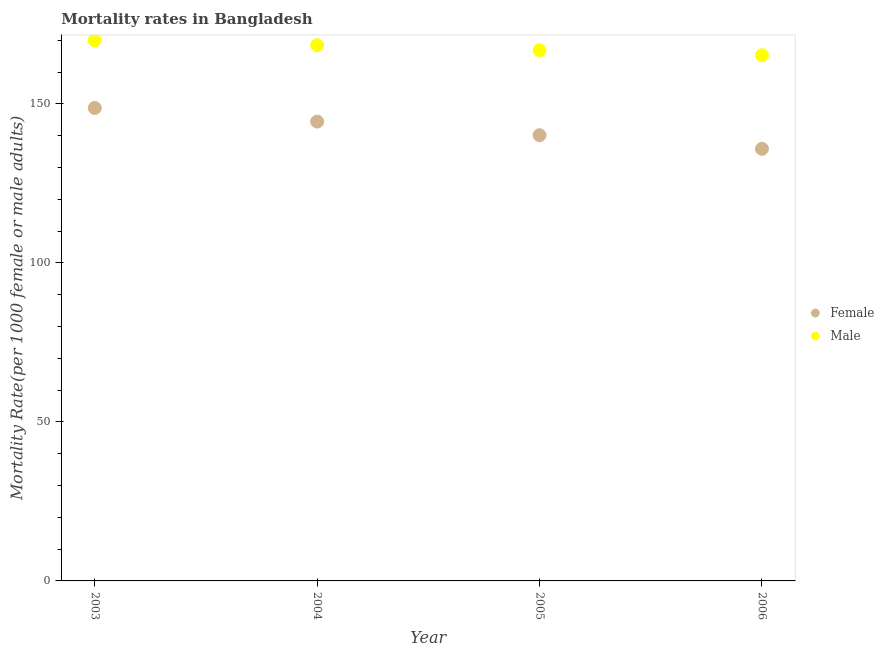What is the female mortality rate in 2004?
Offer a very short reply. 144.42. Across all years, what is the maximum female mortality rate?
Your response must be concise. 148.7. Across all years, what is the minimum male mortality rate?
Make the answer very short. 165.27. In which year was the female mortality rate maximum?
Keep it short and to the point. 2003. In which year was the male mortality rate minimum?
Keep it short and to the point. 2006. What is the total male mortality rate in the graph?
Provide a succinct answer. 670.5. What is the difference between the male mortality rate in 2003 and that in 2005?
Offer a terse response. 3.13. What is the difference between the female mortality rate in 2003 and the male mortality rate in 2005?
Offer a very short reply. -18.14. What is the average male mortality rate per year?
Provide a succinct answer. 167.62. In the year 2005, what is the difference between the female mortality rate and male mortality rate?
Your answer should be compact. -26.7. In how many years, is the female mortality rate greater than 110?
Give a very brief answer. 4. What is the ratio of the male mortality rate in 2003 to that in 2004?
Offer a very short reply. 1.01. What is the difference between the highest and the second highest male mortality rate?
Your answer should be compact. 1.57. What is the difference between the highest and the lowest male mortality rate?
Provide a short and direct response. 4.7. Does the female mortality rate monotonically increase over the years?
Ensure brevity in your answer.  No. Is the male mortality rate strictly greater than the female mortality rate over the years?
Provide a short and direct response. Yes. Is the female mortality rate strictly less than the male mortality rate over the years?
Give a very brief answer. Yes. How many years are there in the graph?
Your answer should be very brief. 4. What is the difference between two consecutive major ticks on the Y-axis?
Provide a succinct answer. 50. How are the legend labels stacked?
Ensure brevity in your answer.  Vertical. What is the title of the graph?
Offer a very short reply. Mortality rates in Bangladesh. Does "International Tourists" appear as one of the legend labels in the graph?
Your answer should be very brief. No. What is the label or title of the Y-axis?
Provide a succinct answer. Mortality Rate(per 1000 female or male adults). What is the Mortality Rate(per 1000 female or male adults) in Female in 2003?
Make the answer very short. 148.7. What is the Mortality Rate(per 1000 female or male adults) in Male in 2003?
Give a very brief answer. 169.97. What is the Mortality Rate(per 1000 female or male adults) in Female in 2004?
Your response must be concise. 144.42. What is the Mortality Rate(per 1000 female or male adults) in Male in 2004?
Give a very brief answer. 168.41. What is the Mortality Rate(per 1000 female or male adults) of Female in 2005?
Your response must be concise. 140.14. What is the Mortality Rate(per 1000 female or male adults) of Male in 2005?
Provide a short and direct response. 166.84. What is the Mortality Rate(per 1000 female or male adults) in Female in 2006?
Offer a terse response. 135.86. What is the Mortality Rate(per 1000 female or male adults) of Male in 2006?
Your response must be concise. 165.27. Across all years, what is the maximum Mortality Rate(per 1000 female or male adults) of Female?
Offer a very short reply. 148.7. Across all years, what is the maximum Mortality Rate(per 1000 female or male adults) in Male?
Your answer should be very brief. 169.97. Across all years, what is the minimum Mortality Rate(per 1000 female or male adults) of Female?
Your response must be concise. 135.86. Across all years, what is the minimum Mortality Rate(per 1000 female or male adults) in Male?
Provide a succinct answer. 165.27. What is the total Mortality Rate(per 1000 female or male adults) of Female in the graph?
Provide a short and direct response. 569.11. What is the total Mortality Rate(per 1000 female or male adults) in Male in the graph?
Your answer should be compact. 670.5. What is the difference between the Mortality Rate(per 1000 female or male adults) in Female in 2003 and that in 2004?
Give a very brief answer. 4.28. What is the difference between the Mortality Rate(per 1000 female or male adults) in Male in 2003 and that in 2004?
Your answer should be very brief. 1.57. What is the difference between the Mortality Rate(per 1000 female or male adults) in Female in 2003 and that in 2005?
Offer a very short reply. 8.56. What is the difference between the Mortality Rate(per 1000 female or male adults) of Male in 2003 and that in 2005?
Give a very brief answer. 3.13. What is the difference between the Mortality Rate(per 1000 female or male adults) of Female in 2003 and that in 2006?
Offer a very short reply. 12.84. What is the difference between the Mortality Rate(per 1000 female or male adults) in Female in 2004 and that in 2005?
Ensure brevity in your answer.  4.28. What is the difference between the Mortality Rate(per 1000 female or male adults) of Male in 2004 and that in 2005?
Offer a very short reply. 1.57. What is the difference between the Mortality Rate(per 1000 female or male adults) in Female in 2004 and that in 2006?
Offer a very short reply. 8.56. What is the difference between the Mortality Rate(per 1000 female or male adults) in Male in 2004 and that in 2006?
Your answer should be very brief. 3.13. What is the difference between the Mortality Rate(per 1000 female or male adults) in Female in 2005 and that in 2006?
Provide a succinct answer. 4.28. What is the difference between the Mortality Rate(per 1000 female or male adults) of Male in 2005 and that in 2006?
Your answer should be compact. 1.57. What is the difference between the Mortality Rate(per 1000 female or male adults) of Female in 2003 and the Mortality Rate(per 1000 female or male adults) of Male in 2004?
Provide a succinct answer. -19.71. What is the difference between the Mortality Rate(per 1000 female or male adults) of Female in 2003 and the Mortality Rate(per 1000 female or male adults) of Male in 2005?
Offer a terse response. -18.14. What is the difference between the Mortality Rate(per 1000 female or male adults) in Female in 2003 and the Mortality Rate(per 1000 female or male adults) in Male in 2006?
Keep it short and to the point. -16.57. What is the difference between the Mortality Rate(per 1000 female or male adults) in Female in 2004 and the Mortality Rate(per 1000 female or male adults) in Male in 2005?
Your answer should be compact. -22.42. What is the difference between the Mortality Rate(per 1000 female or male adults) of Female in 2004 and the Mortality Rate(per 1000 female or male adults) of Male in 2006?
Provide a succinct answer. -20.86. What is the difference between the Mortality Rate(per 1000 female or male adults) of Female in 2005 and the Mortality Rate(per 1000 female or male adults) of Male in 2006?
Ensure brevity in your answer.  -25.14. What is the average Mortality Rate(per 1000 female or male adults) of Female per year?
Your answer should be compact. 142.28. What is the average Mortality Rate(per 1000 female or male adults) of Male per year?
Keep it short and to the point. 167.62. In the year 2003, what is the difference between the Mortality Rate(per 1000 female or male adults) in Female and Mortality Rate(per 1000 female or male adults) in Male?
Provide a short and direct response. -21.27. In the year 2004, what is the difference between the Mortality Rate(per 1000 female or male adults) of Female and Mortality Rate(per 1000 female or male adults) of Male?
Make the answer very short. -23.99. In the year 2005, what is the difference between the Mortality Rate(per 1000 female or male adults) of Female and Mortality Rate(per 1000 female or male adults) of Male?
Offer a very short reply. -26.7. In the year 2006, what is the difference between the Mortality Rate(per 1000 female or male adults) of Female and Mortality Rate(per 1000 female or male adults) of Male?
Keep it short and to the point. -29.42. What is the ratio of the Mortality Rate(per 1000 female or male adults) in Female in 2003 to that in 2004?
Your answer should be very brief. 1.03. What is the ratio of the Mortality Rate(per 1000 female or male adults) of Male in 2003 to that in 2004?
Your answer should be very brief. 1.01. What is the ratio of the Mortality Rate(per 1000 female or male adults) of Female in 2003 to that in 2005?
Offer a terse response. 1.06. What is the ratio of the Mortality Rate(per 1000 female or male adults) in Male in 2003 to that in 2005?
Give a very brief answer. 1.02. What is the ratio of the Mortality Rate(per 1000 female or male adults) of Female in 2003 to that in 2006?
Give a very brief answer. 1.09. What is the ratio of the Mortality Rate(per 1000 female or male adults) of Male in 2003 to that in 2006?
Your response must be concise. 1.03. What is the ratio of the Mortality Rate(per 1000 female or male adults) in Female in 2004 to that in 2005?
Provide a short and direct response. 1.03. What is the ratio of the Mortality Rate(per 1000 female or male adults) in Male in 2004 to that in 2005?
Your answer should be compact. 1.01. What is the ratio of the Mortality Rate(per 1000 female or male adults) in Female in 2004 to that in 2006?
Give a very brief answer. 1.06. What is the ratio of the Mortality Rate(per 1000 female or male adults) in Male in 2004 to that in 2006?
Provide a short and direct response. 1.02. What is the ratio of the Mortality Rate(per 1000 female or male adults) in Female in 2005 to that in 2006?
Make the answer very short. 1.03. What is the ratio of the Mortality Rate(per 1000 female or male adults) in Male in 2005 to that in 2006?
Give a very brief answer. 1.01. What is the difference between the highest and the second highest Mortality Rate(per 1000 female or male adults) of Female?
Offer a terse response. 4.28. What is the difference between the highest and the second highest Mortality Rate(per 1000 female or male adults) of Male?
Provide a succinct answer. 1.57. What is the difference between the highest and the lowest Mortality Rate(per 1000 female or male adults) in Female?
Provide a succinct answer. 12.84. What is the difference between the highest and the lowest Mortality Rate(per 1000 female or male adults) of Male?
Give a very brief answer. 4.7. 